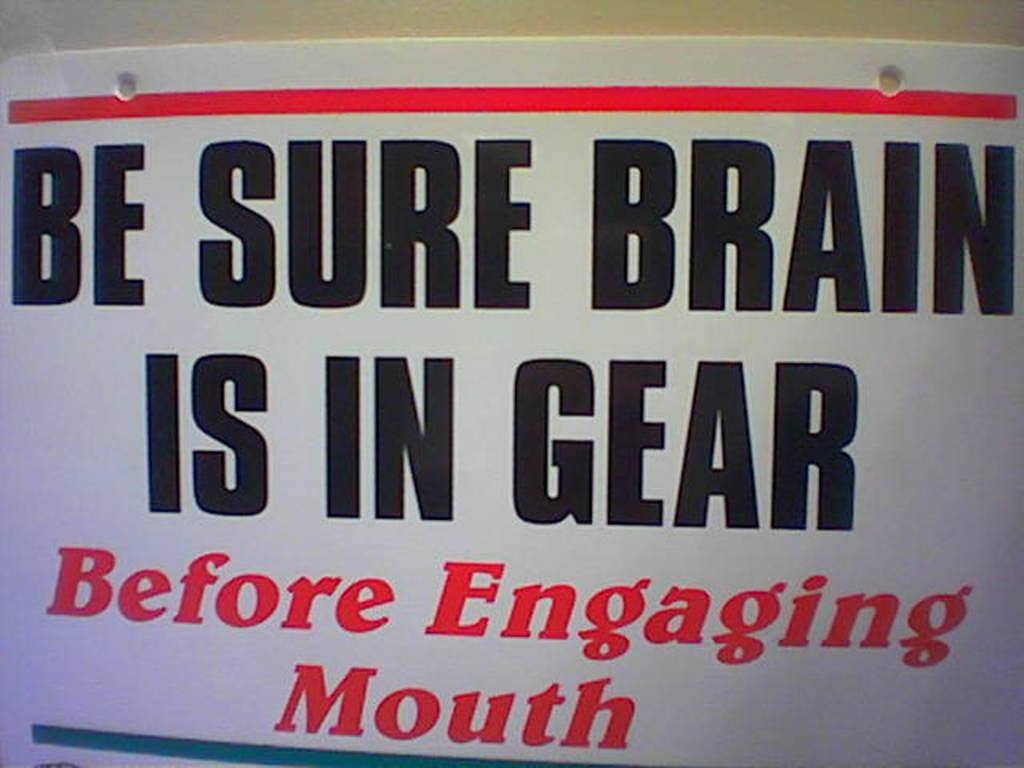<image>
Describe the image concisely. White sign on a wall that says "Be Sure Brain is in Gear". 